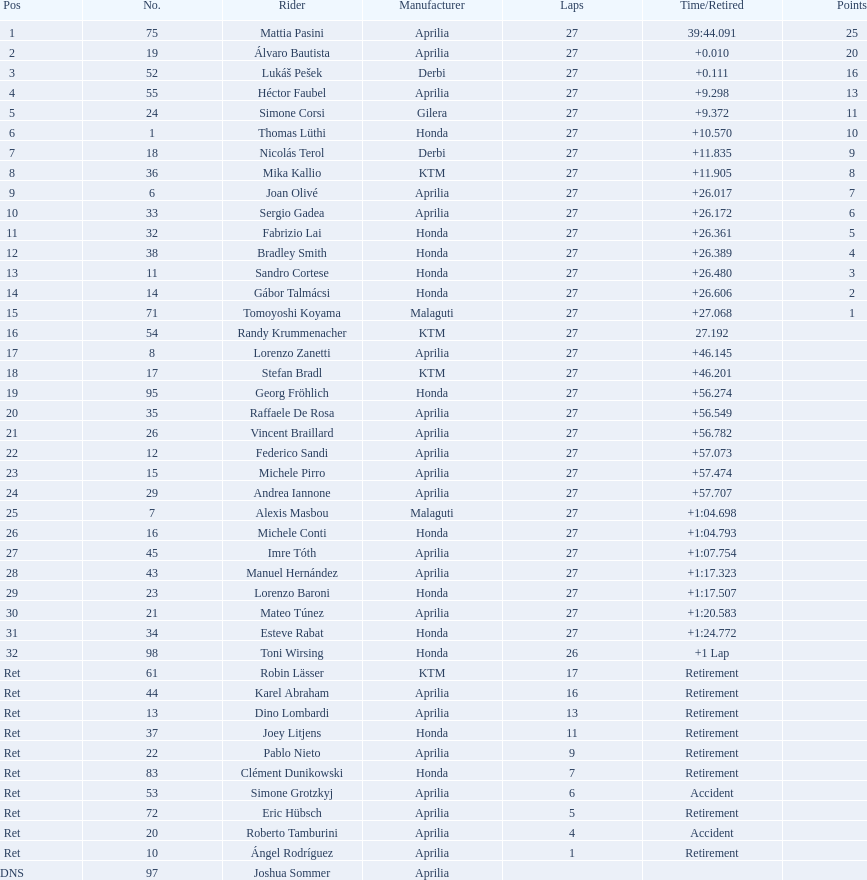How many racers did not use an aprilia or a honda? 9. 